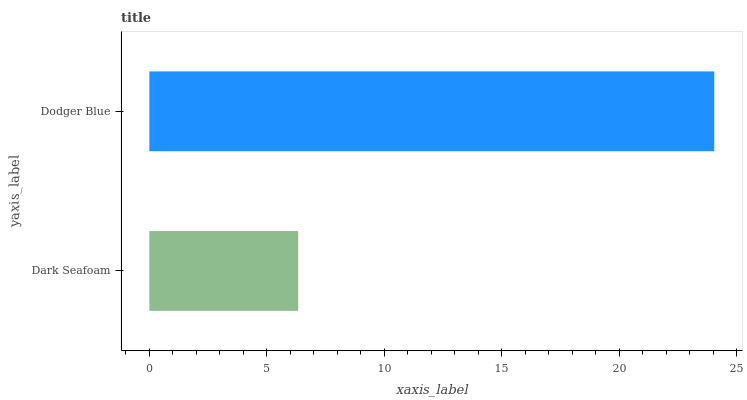Is Dark Seafoam the minimum?
Answer yes or no. Yes. Is Dodger Blue the maximum?
Answer yes or no. Yes. Is Dodger Blue the minimum?
Answer yes or no. No. Is Dodger Blue greater than Dark Seafoam?
Answer yes or no. Yes. Is Dark Seafoam less than Dodger Blue?
Answer yes or no. Yes. Is Dark Seafoam greater than Dodger Blue?
Answer yes or no. No. Is Dodger Blue less than Dark Seafoam?
Answer yes or no. No. Is Dodger Blue the high median?
Answer yes or no. Yes. Is Dark Seafoam the low median?
Answer yes or no. Yes. Is Dark Seafoam the high median?
Answer yes or no. No. Is Dodger Blue the low median?
Answer yes or no. No. 